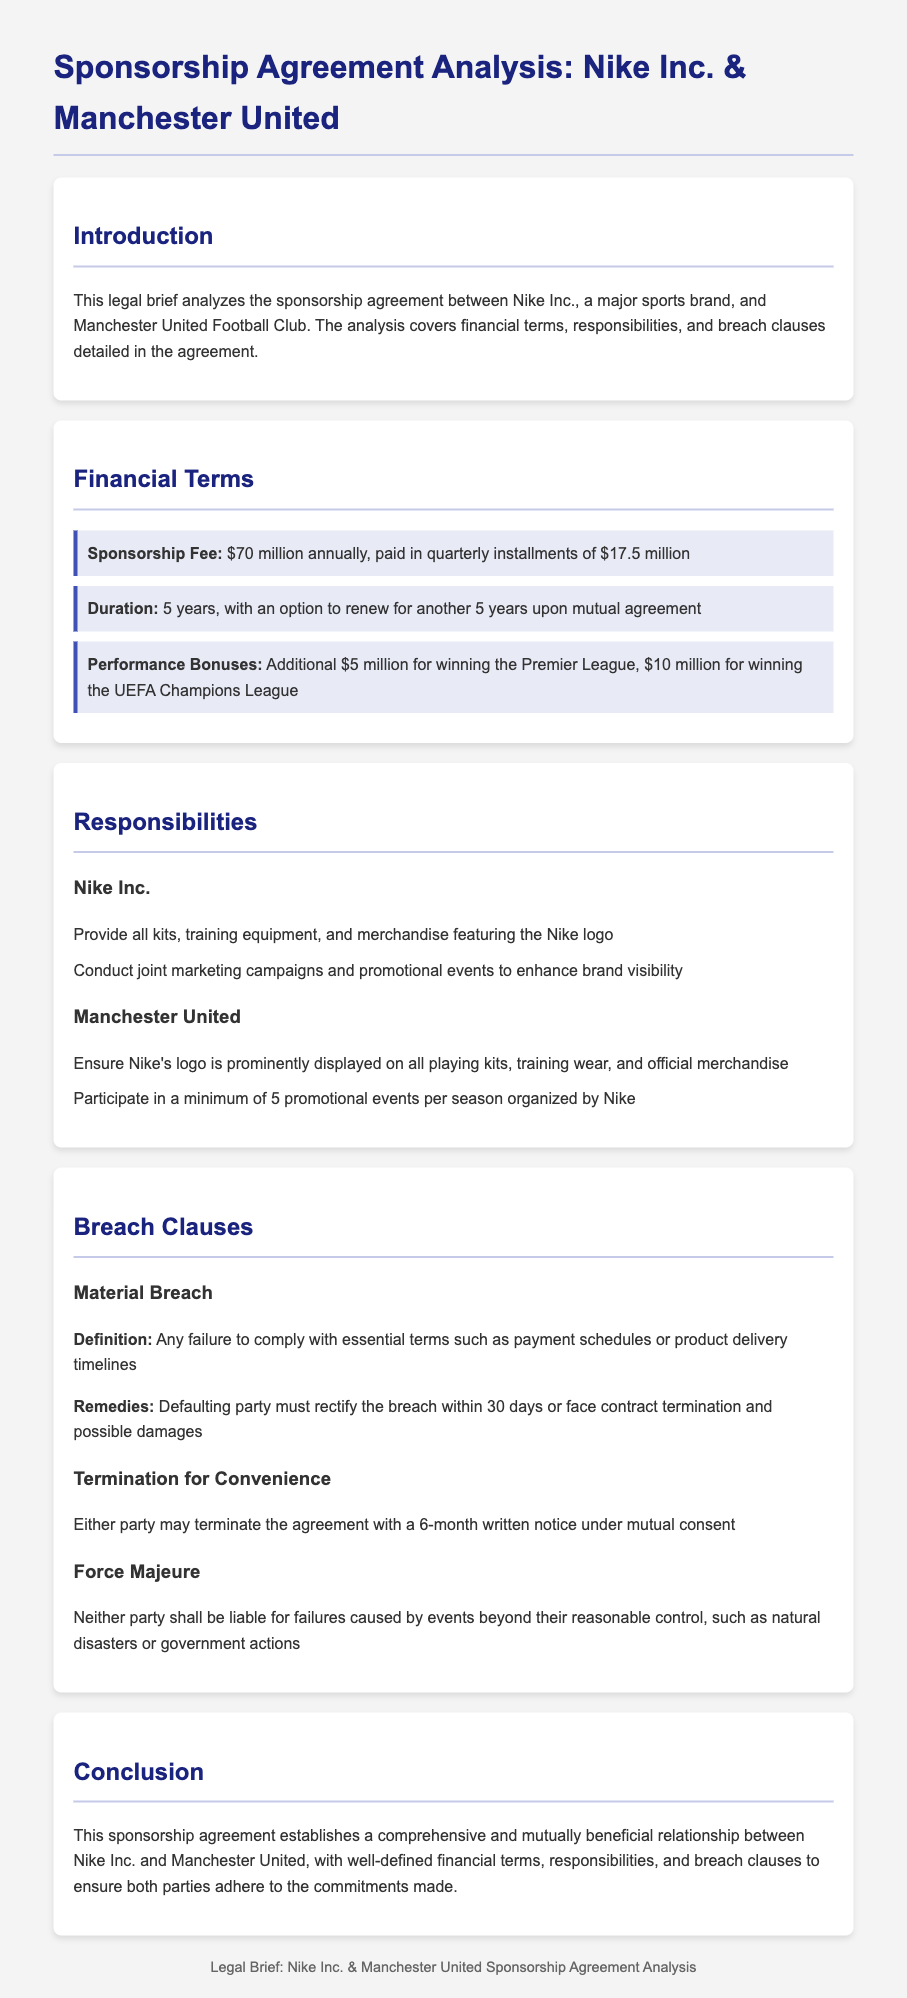What is the annual sponsorship fee? The annual sponsorship fee is clearly stated in the financial terms section of the document.
Answer: $70 million What are the performance bonuses for winning the Premier League? The performance bonuses are outlined in the financial terms section of the document.
Answer: $5 million How long is the duration of the sponsorship agreement? The duration is specified in the financial terms section of the agreement.
Answer: 5 years What is Nike Inc.'s responsibility regarding merchandise? Nike Inc.'s responsibilities are listed under the responsibilities section of the document.
Answer: Provide all kits, training equipment, and merchandise featuring the Nike logo What notice period is required for termination for convenience? The notice period is stated in the breach clauses section of the document.
Answer: 6 months What is defined as a material breach? The definition of material breach is explained in the breach clauses section.
Answer: Any failure to comply with essential terms such as payment schedules or product delivery timelines What must happen if a party defaults on the contract? The obligations after a default are detailed in the breach clauses section of the document.
Answer: Rectify the breach within 30 days or face contract termination and possible damages What type of events does the force majeure clause cover? The types of events are mentioned in the breach clauses section, describing the causes for liability exemption.
Answer: Natural disasters or government actions What relationship does the conclusion suggest exists between the parties? The conclusion summarizes the overall nature of the agreement.
Answer: A comprehensive and mutually beneficial relationship 